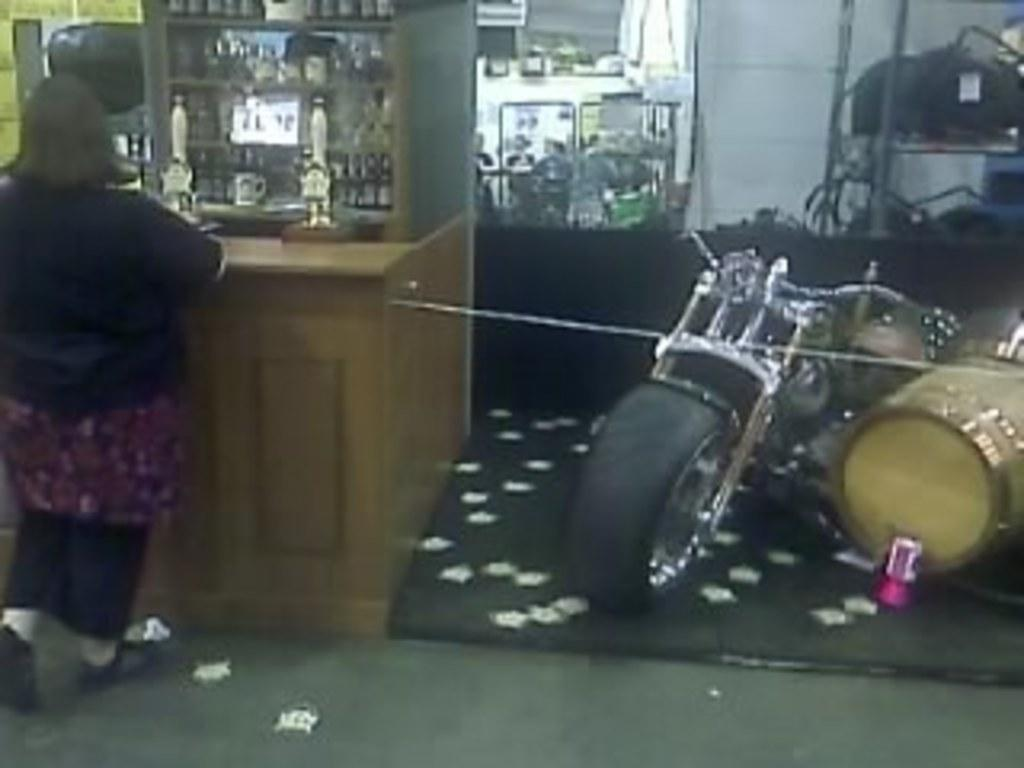What is the woman doing in the image? The woman is standing beside a table in the image. What objects are on the table? There are bottles and racks on the table. What can be seen in the background of the image? There is a bike, drums, and a wall in the background. How many team members are visible in the image? There is no team or team members present in the image. What type of ocean can be seen in the background of the image? There is no ocean visible in the image; it features a wall, bike, and drums in the background. 